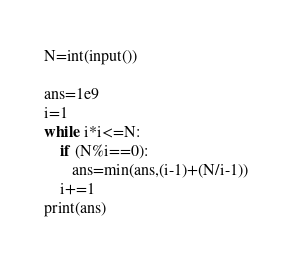Convert code to text. <code><loc_0><loc_0><loc_500><loc_500><_Python_>N=int(input())

ans=1e9
i=1
while i*i<=N:
    if (N%i==0):
       ans=min(ans,(i-1)+(N/i-1)) 
    i+=1
print(ans)</code> 